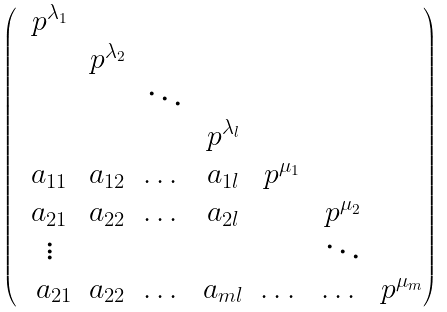Convert formula to latex. <formula><loc_0><loc_0><loc_500><loc_500>\begin{pmatrix} \ p ^ { \lambda _ { 1 } } \\ \ & p ^ { \lambda _ { 2 } } \\ \ & & \ddots \\ \ & & & p ^ { \lambda _ { l } } \\ \ a _ { 1 1 } & a _ { 1 2 } & \hdots \ & a _ { 1 l } & p ^ { \mu _ { 1 } } \\ \ a _ { 2 1 } & a _ { 2 2 } & \hdots \ & a _ { 2 l } & & p ^ { \mu _ { 2 } } \\ \ \vdots & & & & & \ddots \\ \ \ a _ { 2 1 } & a _ { 2 2 } & \hdots \ & a _ { m l } & \hdots \ & \hdots \ & p ^ { \mu _ { m } } \\ \end{pmatrix}</formula> 